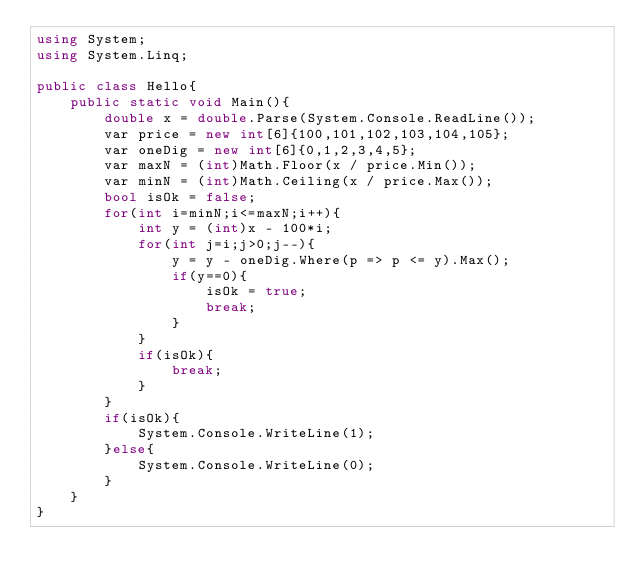<code> <loc_0><loc_0><loc_500><loc_500><_C#_>using System;
using System.Linq;

public class Hello{
    public static void Main(){
        double x = double.Parse(System.Console.ReadLine());
        var price = new int[6]{100,101,102,103,104,105};
        var oneDig = new int[6]{0,1,2,3,4,5};
        var maxN = (int)Math.Floor(x / price.Min());
        var minN = (int)Math.Ceiling(x / price.Max());
        bool isOk = false;
        for(int i=minN;i<=maxN;i++){
            int y = (int)x - 100*i;
            for(int j=i;j>0;j--){
                y = y - oneDig.Where(p => p <= y).Max();
                if(y==0){
                    isOk = true;
                    break;
                }
            }
            if(isOk){
                break;
            }
        }
        if(isOk){
            System.Console.WriteLine(1);
        }else{
            System.Console.WriteLine(0);
        }
    }
}</code> 